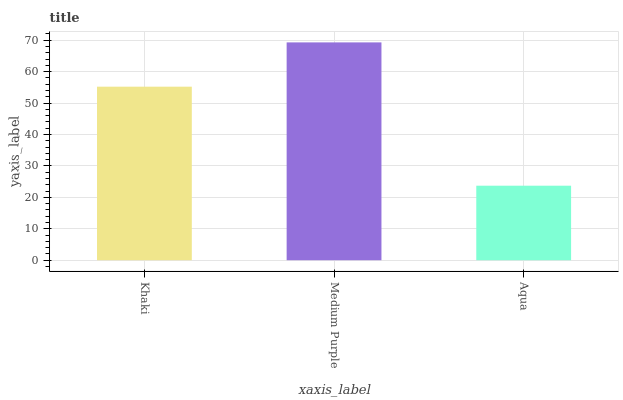Is Aqua the minimum?
Answer yes or no. Yes. Is Medium Purple the maximum?
Answer yes or no. Yes. Is Medium Purple the minimum?
Answer yes or no. No. Is Aqua the maximum?
Answer yes or no. No. Is Medium Purple greater than Aqua?
Answer yes or no. Yes. Is Aqua less than Medium Purple?
Answer yes or no. Yes. Is Aqua greater than Medium Purple?
Answer yes or no. No. Is Medium Purple less than Aqua?
Answer yes or no. No. Is Khaki the high median?
Answer yes or no. Yes. Is Khaki the low median?
Answer yes or no. Yes. Is Medium Purple the high median?
Answer yes or no. No. Is Aqua the low median?
Answer yes or no. No. 